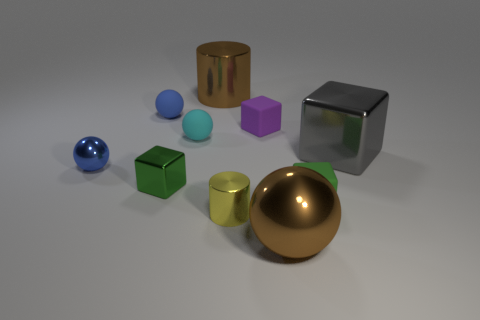Subtract all gray cubes. How many cubes are left? 3 Subtract all small spheres. How many spheres are left? 1 Subtract all yellow balls. Subtract all purple blocks. How many balls are left? 4 Subtract all cylinders. How many objects are left? 8 Add 6 matte spheres. How many matte spheres exist? 8 Subtract 1 yellow cylinders. How many objects are left? 9 Subtract all small cubes. Subtract all gray objects. How many objects are left? 6 Add 8 cyan rubber balls. How many cyan rubber balls are left? 9 